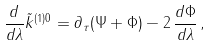Convert formula to latex. <formula><loc_0><loc_0><loc_500><loc_500>\frac { d } { d \lambda } \tilde { k } ^ { ( 1 ) 0 } = \partial _ { \tau } ( \Psi + \Phi ) - 2 \, \frac { d \Phi } { d \lambda } \, ,</formula> 